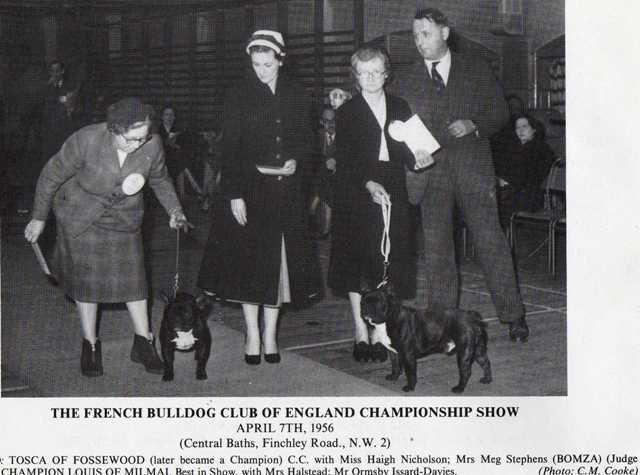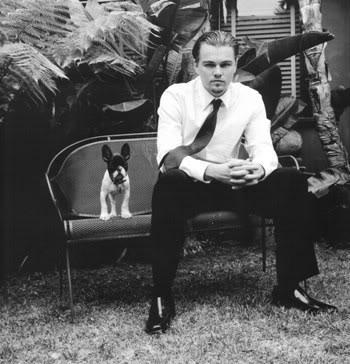The first image is the image on the left, the second image is the image on the right. Analyze the images presented: Is the assertion "The right image shows a person standing to one side of two black pugs with white chest marks and holding onto a leash." valid? Answer yes or no. No. 